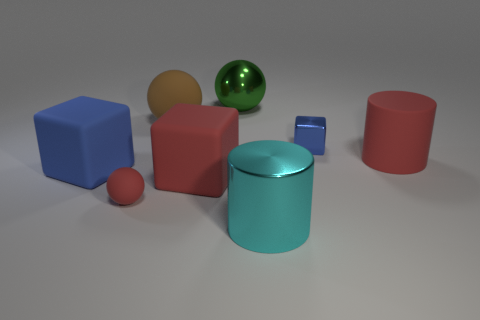Add 1 large red spheres. How many objects exist? 9 Subtract all balls. How many objects are left? 5 Subtract all blue blocks. How many blocks are left? 1 Subtract all small blue shiny cubes. How many cubes are left? 2 Subtract 0 purple blocks. How many objects are left? 8 Subtract 2 cylinders. How many cylinders are left? 0 Subtract all green spheres. Subtract all green cylinders. How many spheres are left? 2 Subtract all cyan blocks. How many red cylinders are left? 1 Subtract all shiny blocks. Subtract all large blocks. How many objects are left? 5 Add 1 cubes. How many cubes are left? 4 